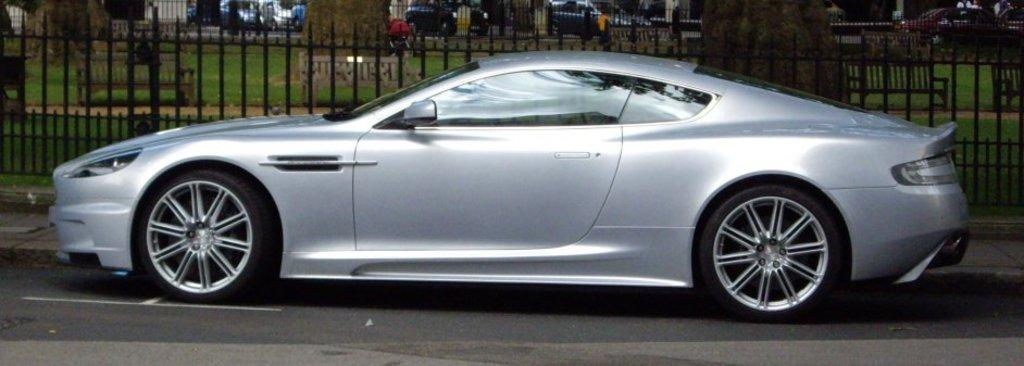What is the main subject of the image? The main subject of the image is a car. Where is the car located in the image? The car is on the road in the image. What can be seen in the background of the image? There is a fence and benches in the background of the image. Are there any other vehicles visible in the image? Yes, there are vehicles in the background of the image. What type of linen is draped over the car in the image? There is no linen draped over the car in the image. How much fuel is left in the car's tank in the image? The image does not provide information about the car's fuel level. What time is displayed on the clock in the image? There is no clock present in the image. 